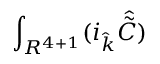Convert formula to latex. <formula><loc_0><loc_0><loc_500><loc_500>\int _ { R ^ { 4 + 1 } } ( i _ { \hat { k } } { \hat { \tilde { C } } } )</formula> 